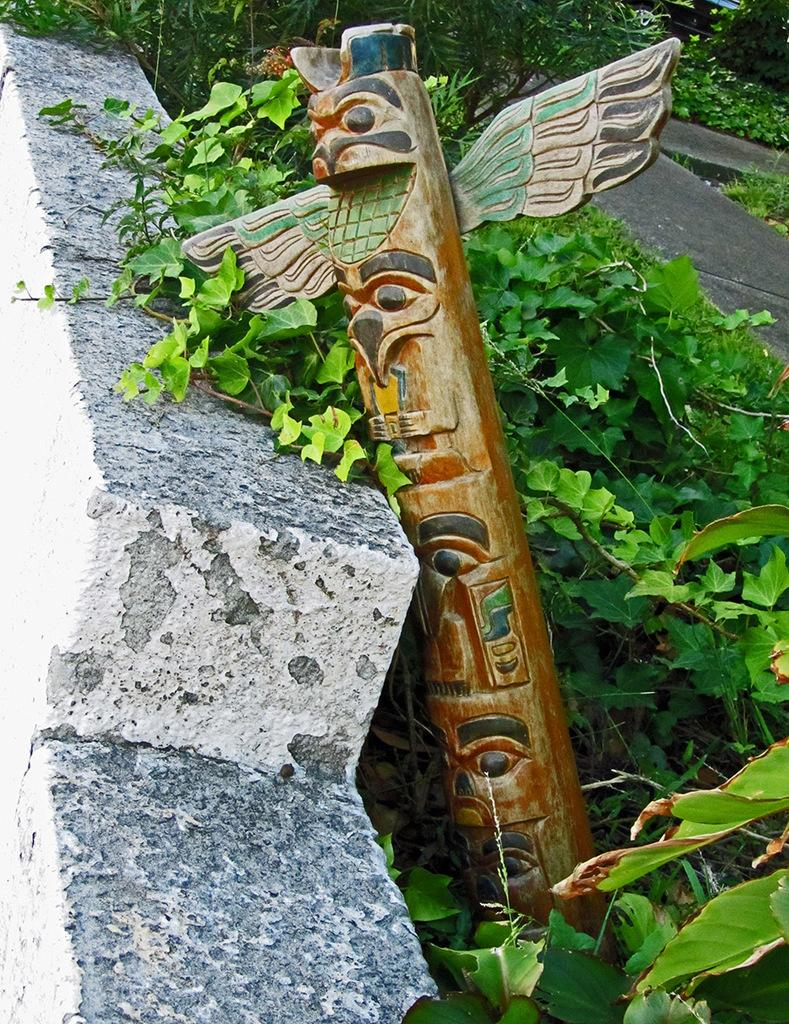What object made of wood can be seen in the image? There is a wooden stick in the image. What type of living organisms are present in the image? There are plants in the image. What type of bear can be seen interacting with the wooden stick in the image? There is no bear present in the image; it only features a wooden stick and plants. How does the wooden stick make the plants feel in the image? The wooden stick does not have the ability to make the plants feel anything, as it is an inanimate object. 